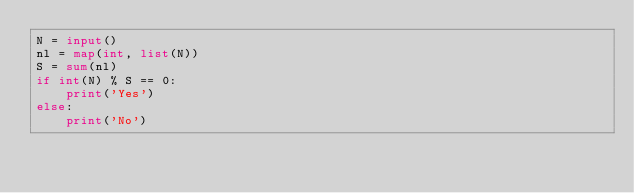Convert code to text. <code><loc_0><loc_0><loc_500><loc_500><_Python_>N = input()
nl = map(int, list(N))
S = sum(nl)
if int(N) % S == 0:
    print('Yes')
else:
    print('No')</code> 